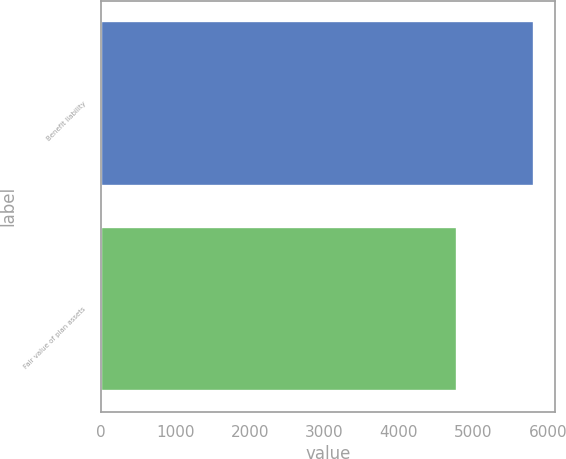Convert chart. <chart><loc_0><loc_0><loc_500><loc_500><bar_chart><fcel>Benefit liability<fcel>Fair value of plan assets<nl><fcel>5806<fcel>4778<nl></chart> 